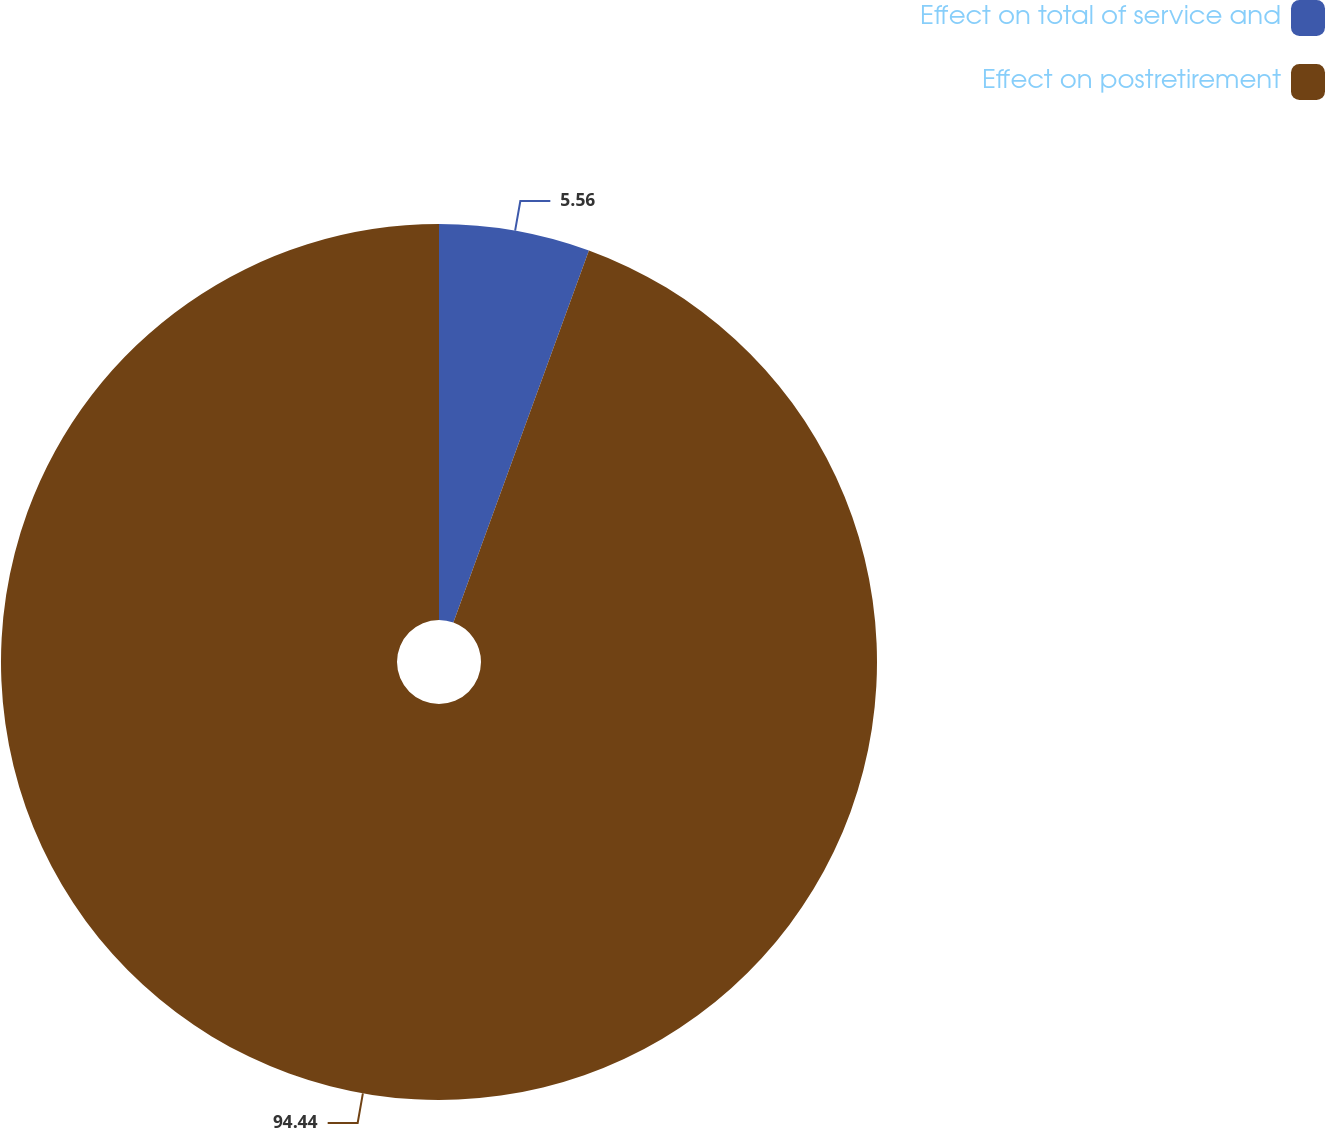Convert chart. <chart><loc_0><loc_0><loc_500><loc_500><pie_chart><fcel>Effect on total of service and<fcel>Effect on postretirement<nl><fcel>5.56%<fcel>94.44%<nl></chart> 